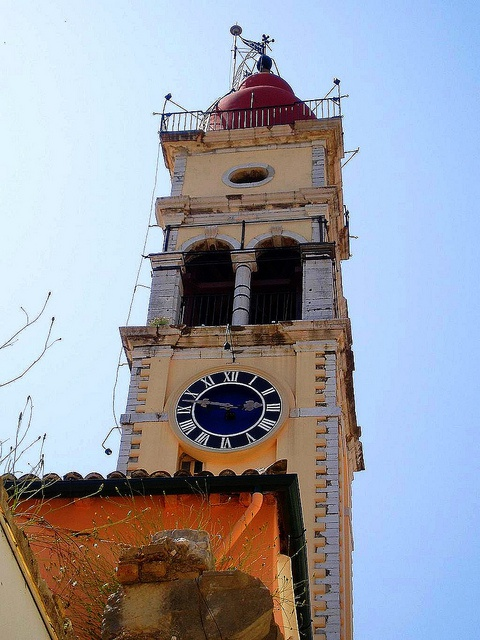Describe the objects in this image and their specific colors. I can see a clock in white, black, gray, lavender, and darkgray tones in this image. 